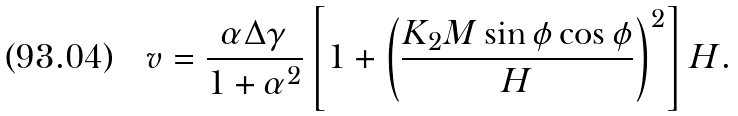Convert formula to latex. <formula><loc_0><loc_0><loc_500><loc_500>v = \frac { \alpha \Delta \gamma } { 1 + \alpha ^ { 2 } } \left [ 1 + \left ( \frac { K _ { 2 } M \sin \phi \cos \phi } { H } \right ) ^ { 2 } \right ] H .</formula> 